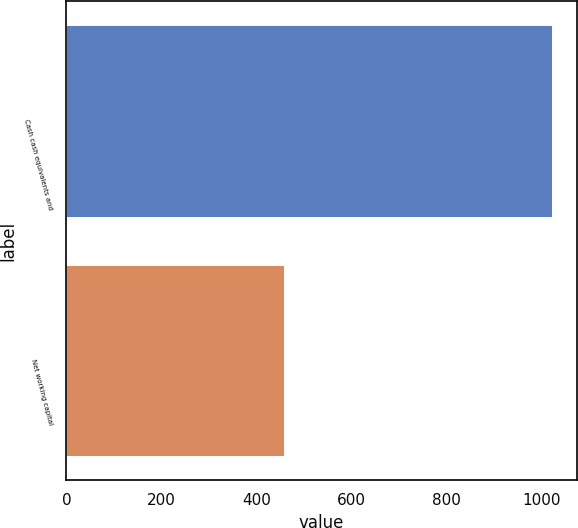Convert chart. <chart><loc_0><loc_0><loc_500><loc_500><bar_chart><fcel>Cash cash equivalents and<fcel>Net working capital<nl><fcel>1022.6<fcel>458.6<nl></chart> 